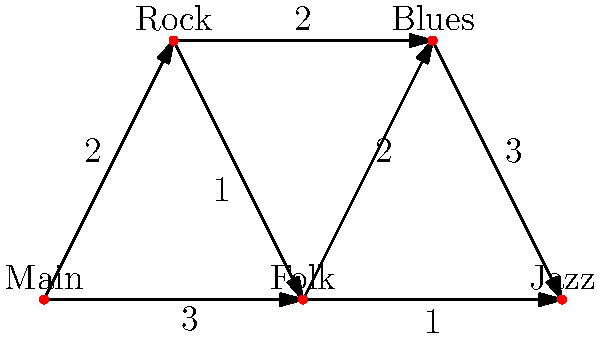At a rock music festival, you need to navigate between different stages to catch your favorite acts. The festival layout is represented by the graph above, where each node is a stage and the edges represent paths between stages with their respective walking times in minutes. You start at the Main stage and want to reach the Jazz stage as quickly as possible to see a legendary guitarist perform. What's the shortest time (in minutes) it takes to reach the Jazz stage, and which path should you take? Let's approach this step-by-step using Dijkstra's algorithm:

1) Start at the Main stage with a distance of 0. Set all other distances to infinity.

2) From Main, we can reach:
   - Rock: 2 minutes
   - Folk: 3 minutes
   
3) Choose Rock (2 min). From Rock, we can reach:
   - Blues: 2 + 2 = 4 minutes
   - Folk: 2 + 1 = 3 minutes (shorter than direct from Main)
   
4) Choose Folk (3 min). From Folk, we can reach:
   - Blues: 3 + 2 = 5 minutes
   - Jazz: 3 + 1 = 4 minutes
   
5) Choose Jazz (4 min). We've reached our destination.

The shortest path is: Main → Folk → Jazz
The total time is 4 minutes.

This path utilizes the traditional stage setup (Main to Folk) and then takes advantage of the quick connection to the Jazz stage, which aligns with the rock frontman's appreciation for traditional setups while efficiently reaching the destination to see the legendary guitarist.
Answer: 4 minutes; Main → Folk → Jazz 